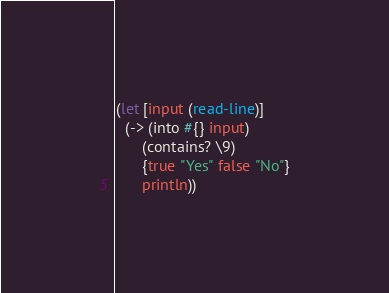Convert code to text. <code><loc_0><loc_0><loc_500><loc_500><_Clojure_>(let [input (read-line)]
  (-> (into #{} input)
      (contains? \9)
      {true "Yes" false "No"}
      println))
</code> 